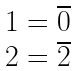<formula> <loc_0><loc_0><loc_500><loc_500>\begin{matrix} 1 = \overline { 0 } \\ 2 = \overline { 2 } \end{matrix}</formula> 